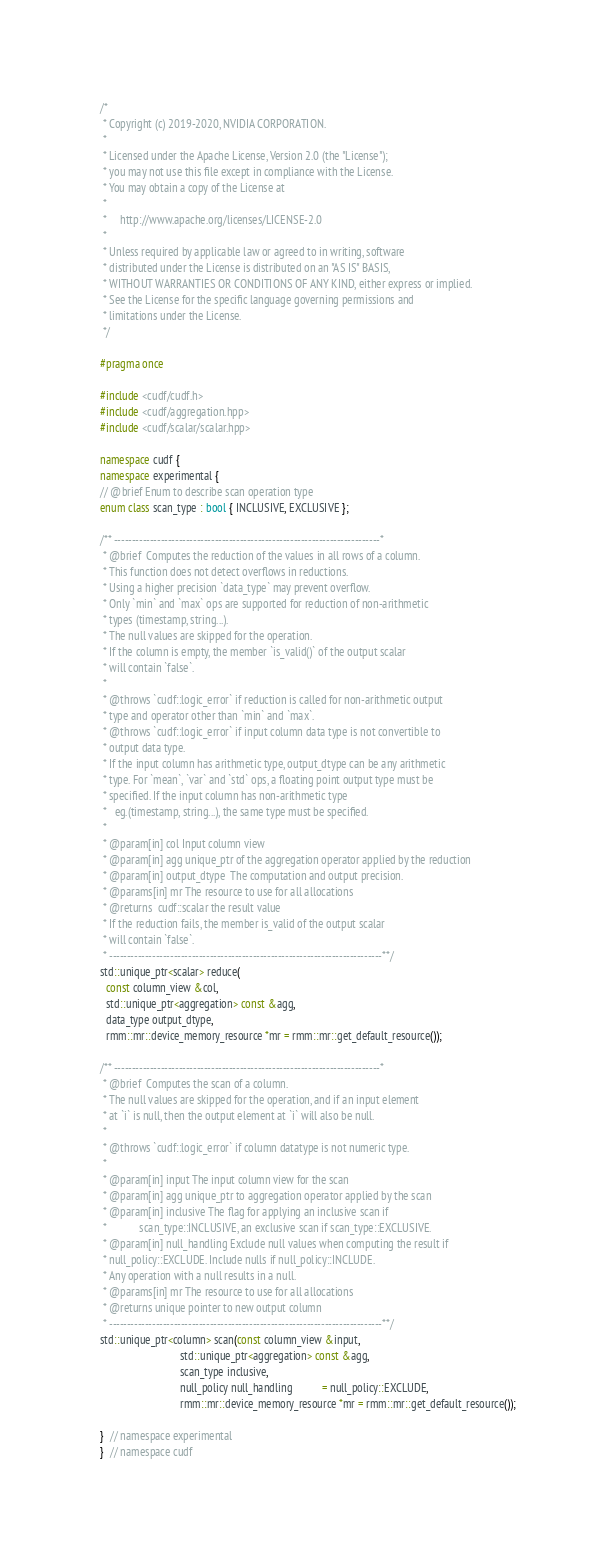<code> <loc_0><loc_0><loc_500><loc_500><_C++_>/*
 * Copyright (c) 2019-2020, NVIDIA CORPORATION.
 *
 * Licensed under the Apache License, Version 2.0 (the "License");
 * you may not use this file except in compliance with the License.
 * You may obtain a copy of the License at
 *
 *     http://www.apache.org/licenses/LICENSE-2.0
 *
 * Unless required by applicable law or agreed to in writing, software
 * distributed under the License is distributed on an "AS IS" BASIS,
 * WITHOUT WARRANTIES OR CONDITIONS OF ANY KIND, either express or implied.
 * See the License for the specific language governing permissions and
 * limitations under the License.
 */

#pragma once

#include <cudf/cudf.h>
#include <cudf/aggregation.hpp>
#include <cudf/scalar/scalar.hpp>

namespace cudf {
namespace experimental {
// @brief Enum to describe scan operation type
enum class scan_type : bool { INCLUSIVE, EXCLUSIVE };

/** --------------------------------------------------------------------------*
 * @brief  Computes the reduction of the values in all rows of a column.
 * This function does not detect overflows in reductions.
 * Using a higher precision `data_type` may prevent overflow.
 * Only `min` and `max` ops are supported for reduction of non-arithmetic
 * types (timestamp, string...).
 * The null values are skipped for the operation.
 * If the column is empty, the member `is_valid()` of the output scalar
 * will contain `false`.
 *
 * @throws `cudf::logic_error` if reduction is called for non-arithmetic output
 * type and operator other than `min` and `max`.
 * @throws `cudf::logic_error` if input column data type is not convertible to
 * output data type.
 * If the input column has arithmetic type, output_dtype can be any arithmetic
 * type. For `mean`, `var` and `std` ops, a floating point output type must be
 * specified. If the input column has non-arithmetic type
 *   eg.(timestamp, string...), the same type must be specified.
 *
 * @param[in] col Input column view
 * @param[in] agg unique_ptr of the aggregation operator applied by the reduction
 * @param[in] output_dtype  The computation and output precision.
 * @params[in] mr The resource to use for all allocations
 * @returns  cudf::scalar the result value
 * If the reduction fails, the member is_valid of the output scalar
 * will contain `false`.
 * ----------------------------------------------------------------------------**/
std::unique_ptr<scalar> reduce(
  const column_view &col,
  std::unique_ptr<aggregation> const &agg,
  data_type output_dtype,
  rmm::mr::device_memory_resource *mr = rmm::mr::get_default_resource());

/** --------------------------------------------------------------------------*
 * @brief  Computes the scan of a column.
 * The null values are skipped for the operation, and if an input element
 * at `i` is null, then the output element at `i` will also be null.
 *
 * @throws `cudf::logic_error` if column datatype is not numeric type.
 *
 * @param[in] input The input column view for the scan
 * @param[in] agg unique_ptr to aggregation operator applied by the scan
 * @param[in] inclusive The flag for applying an inclusive scan if
 *            scan_type::INCLUSIVE, an exclusive scan if scan_type::EXCLUSIVE.
 * @param[in] null_handling Exclude null values when computing the result if
 * null_policy::EXCLUDE. Include nulls if null_policy::INCLUDE.
 * Any operation with a null results in a null.
 * @params[in] mr The resource to use for all allocations
 * @returns unique pointer to new output column
 * ----------------------------------------------------------------------------**/
std::unique_ptr<column> scan(const column_view &input,
                             std::unique_ptr<aggregation> const &agg,
                             scan_type inclusive,
                             null_policy null_handling           = null_policy::EXCLUDE,
                             rmm::mr::device_memory_resource *mr = rmm::mr::get_default_resource());

}  // namespace experimental
}  // namespace cudf
</code> 